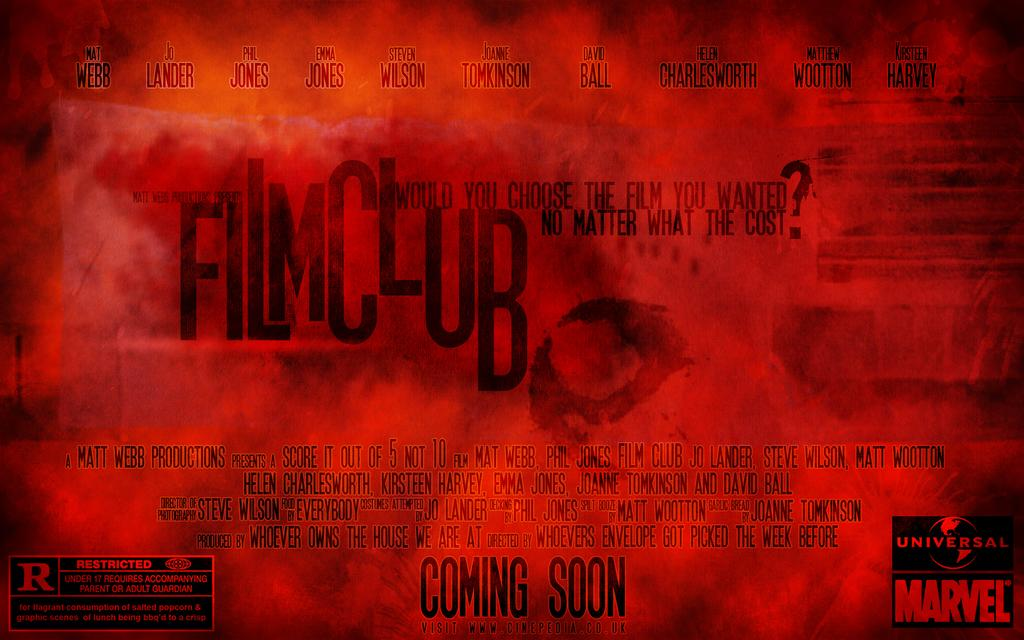What is the main subject in the center of the image? There is a poster in the center of the image. What can be seen on the poster? There is writing on the poster. What type of rock is being used as a partner for the event in the image? There is no rock or event present in the image; it only features a poster with writing on it. 